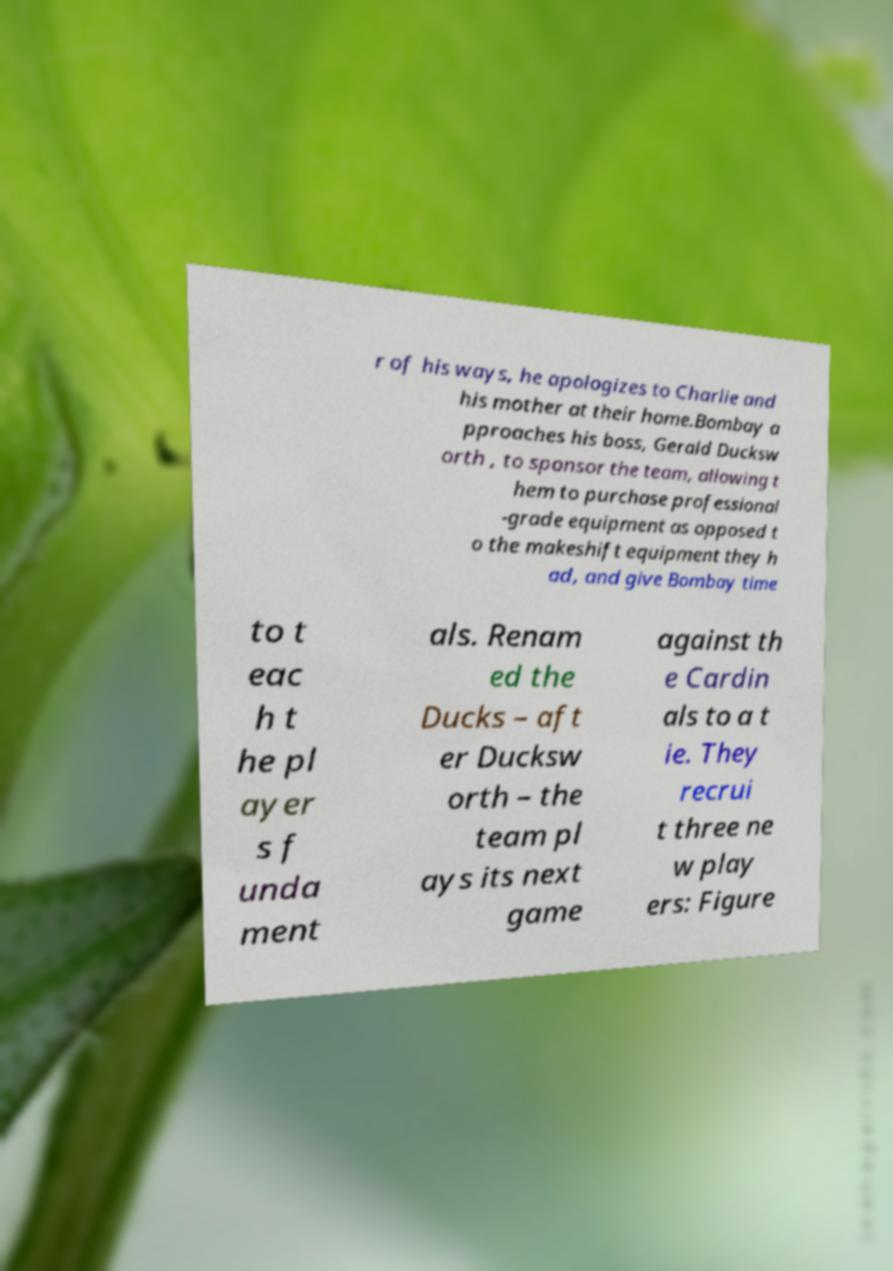I need the written content from this picture converted into text. Can you do that? r of his ways, he apologizes to Charlie and his mother at their home.Bombay a pproaches his boss, Gerald Ducksw orth , to sponsor the team, allowing t hem to purchase professional -grade equipment as opposed t o the makeshift equipment they h ad, and give Bombay time to t eac h t he pl ayer s f unda ment als. Renam ed the Ducks – aft er Ducksw orth – the team pl ays its next game against th e Cardin als to a t ie. They recrui t three ne w play ers: Figure 